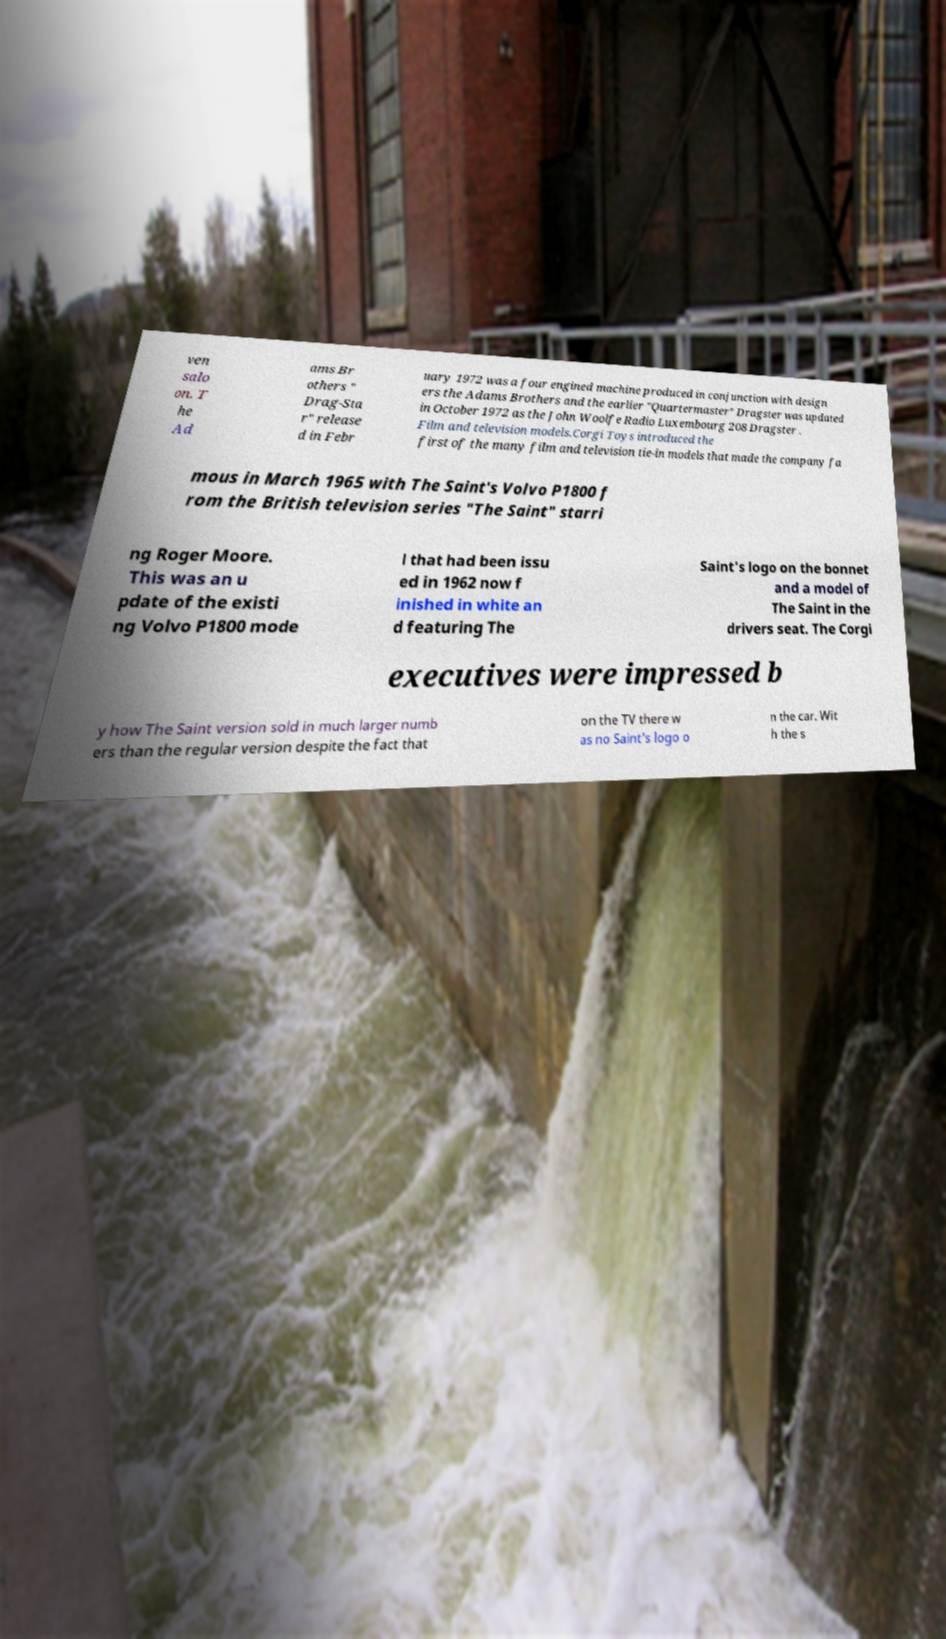Can you read and provide the text displayed in the image?This photo seems to have some interesting text. Can you extract and type it out for me? ven salo on. T he Ad ams Br others " Drag-Sta r" release d in Febr uary 1972 was a four engined machine produced in conjunction with design ers the Adams Brothers and the earlier "Quartermaster" Dragster was updated in October 1972 as the John Woolfe Radio Luxembourg 208 Dragster . Film and television models.Corgi Toys introduced the first of the many film and television tie-in models that made the company fa mous in March 1965 with The Saint's Volvo P1800 f rom the British television series "The Saint" starri ng Roger Moore. This was an u pdate of the existi ng Volvo P1800 mode l that had been issu ed in 1962 now f inished in white an d featuring The Saint's logo on the bonnet and a model of The Saint in the drivers seat. The Corgi executives were impressed b y how The Saint version sold in much larger numb ers than the regular version despite the fact that on the TV there w as no Saint's logo o n the car. Wit h the s 